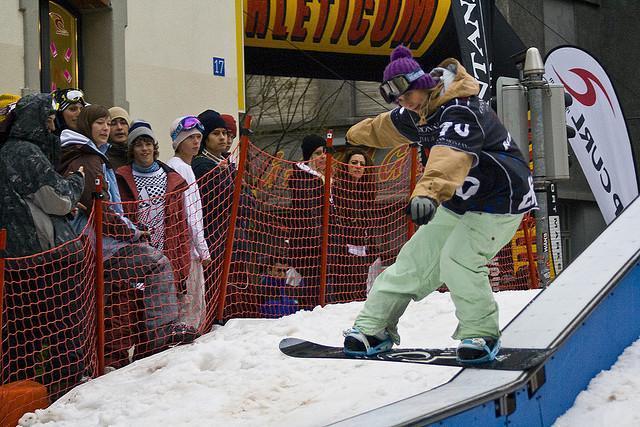How many infants are in the crowd?
Give a very brief answer. 0. How many snowboards are in the picture?
Give a very brief answer. 2. How many people are in the photo?
Give a very brief answer. 9. 